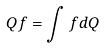<formula> <loc_0><loc_0><loc_500><loc_500>Q f = \int f d Q</formula> 